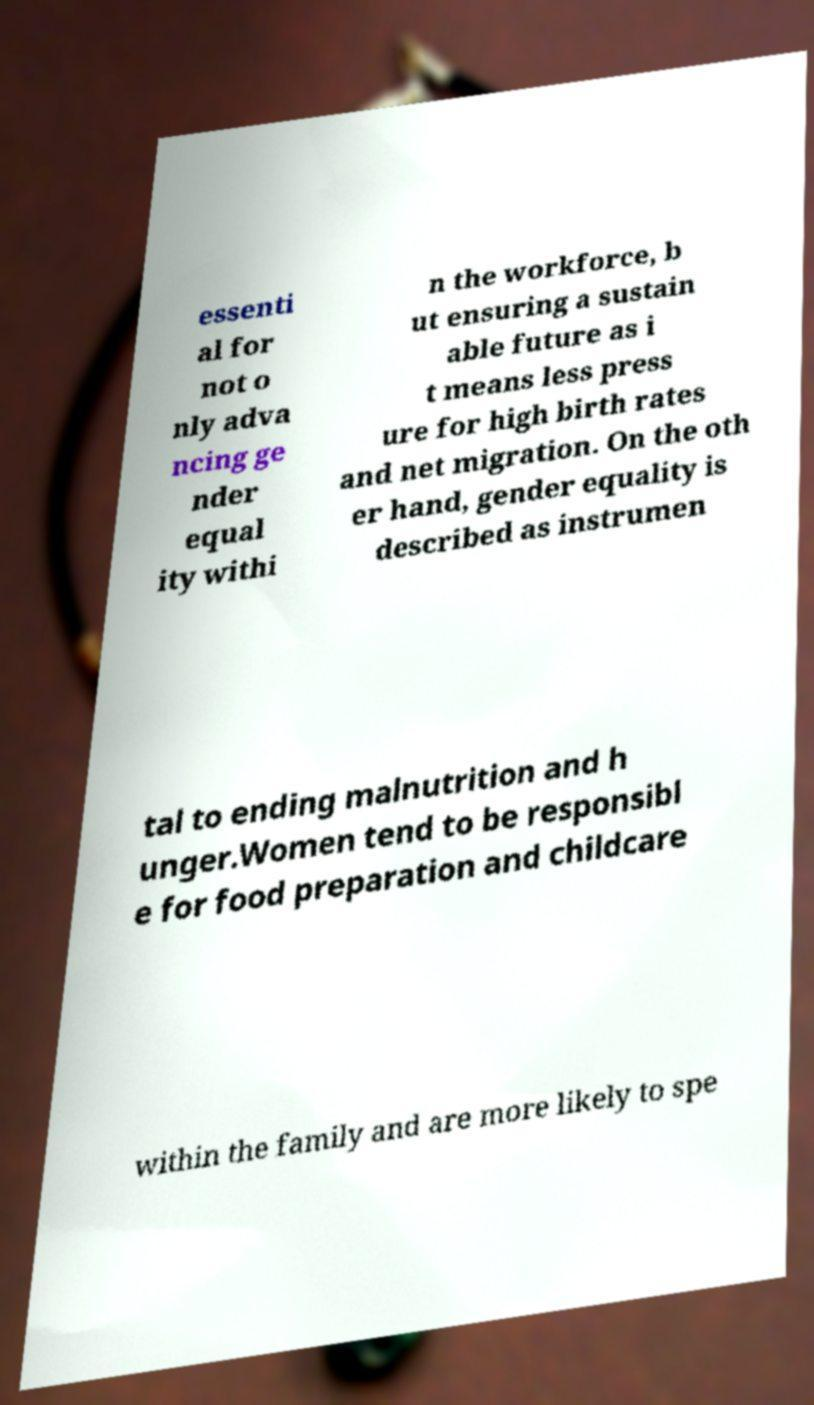There's text embedded in this image that I need extracted. Can you transcribe it verbatim? essenti al for not o nly adva ncing ge nder equal ity withi n the workforce, b ut ensuring a sustain able future as i t means less press ure for high birth rates and net migration. On the oth er hand, gender equality is described as instrumen tal to ending malnutrition and h unger.Women tend to be responsibl e for food preparation and childcare within the family and are more likely to spe 